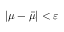<formula> <loc_0><loc_0><loc_500><loc_500>| \mu - \bar { \mu } | < \varepsilon</formula> 